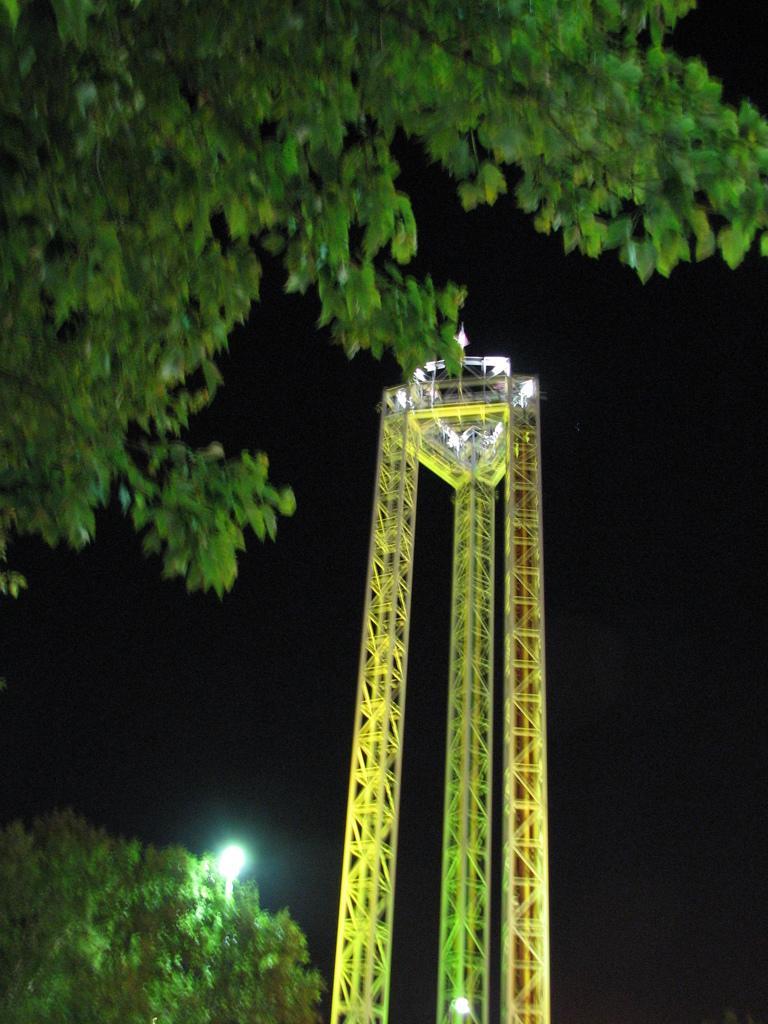How would you summarize this image in a sentence or two? In this image there is a crane, on the left side there are trees. 